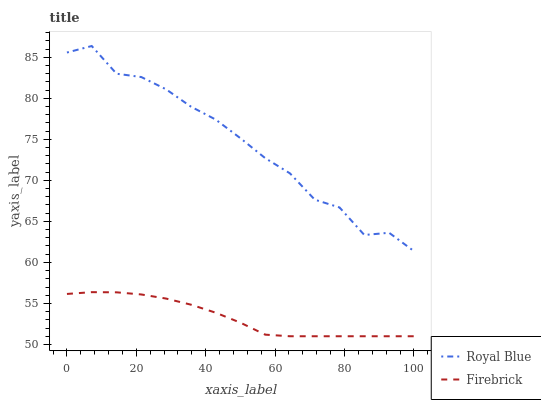Does Firebrick have the minimum area under the curve?
Answer yes or no. Yes. Does Royal Blue have the maximum area under the curve?
Answer yes or no. Yes. Does Firebrick have the maximum area under the curve?
Answer yes or no. No. Is Firebrick the smoothest?
Answer yes or no. Yes. Is Royal Blue the roughest?
Answer yes or no. Yes. Is Firebrick the roughest?
Answer yes or no. No. Does Firebrick have the lowest value?
Answer yes or no. Yes. Does Royal Blue have the highest value?
Answer yes or no. Yes. Does Firebrick have the highest value?
Answer yes or no. No. Is Firebrick less than Royal Blue?
Answer yes or no. Yes. Is Royal Blue greater than Firebrick?
Answer yes or no. Yes. Does Firebrick intersect Royal Blue?
Answer yes or no. No. 